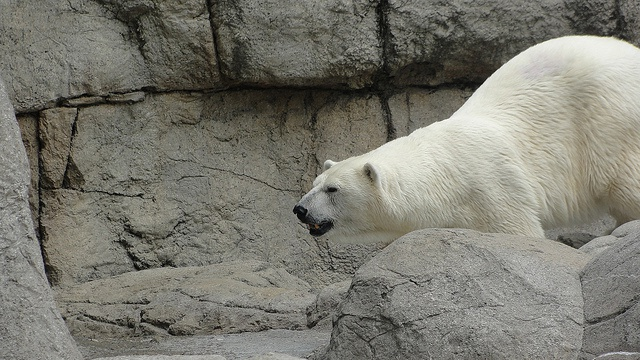Describe the objects in this image and their specific colors. I can see a bear in gray, darkgray, and lightgray tones in this image. 